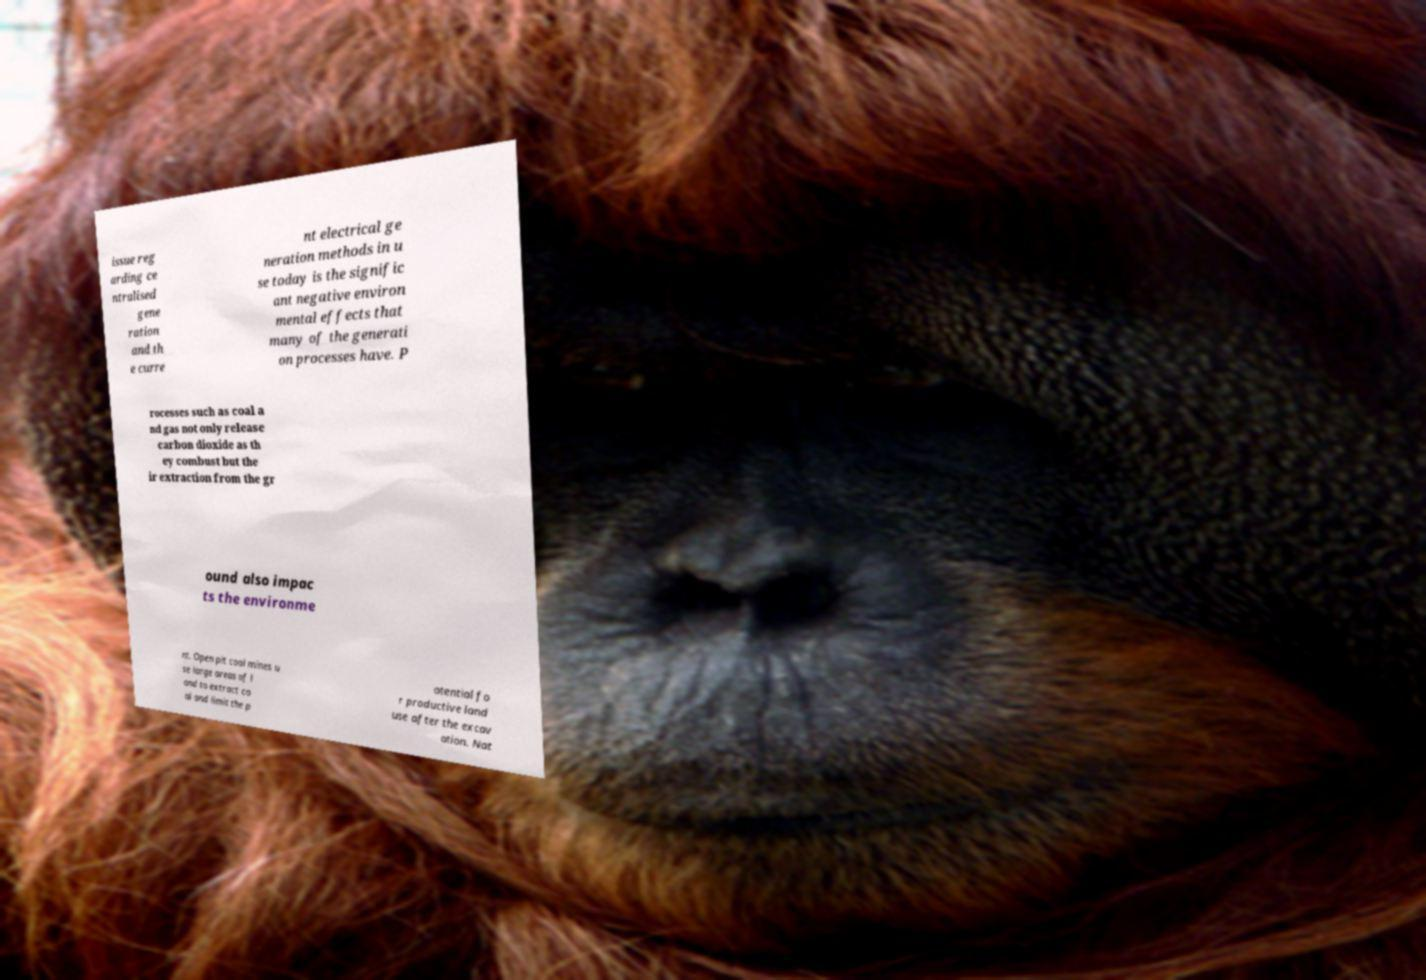Please read and relay the text visible in this image. What does it say? issue reg arding ce ntralised gene ration and th e curre nt electrical ge neration methods in u se today is the signific ant negative environ mental effects that many of the generati on processes have. P rocesses such as coal a nd gas not only release carbon dioxide as th ey combust but the ir extraction from the gr ound also impac ts the environme nt. Open pit coal mines u se large areas of l and to extract co al and limit the p otential fo r productive land use after the excav ation. Nat 